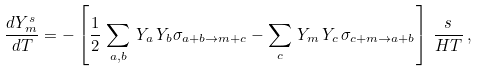Convert formula to latex. <formula><loc_0><loc_0><loc_500><loc_500>\frac { d Y ^ { s } _ { m } } { d T } = - \left [ \frac { 1 } { 2 } \, \sum _ { a , b } \, Y _ { a } \, Y _ { b } \sigma _ { a + b \to m + c } - \sum _ { c } \, Y _ { m } \, Y _ { c } \, \sigma _ { c + m \to a + b } \right ] \, \frac { s } { H T } \, ,</formula> 